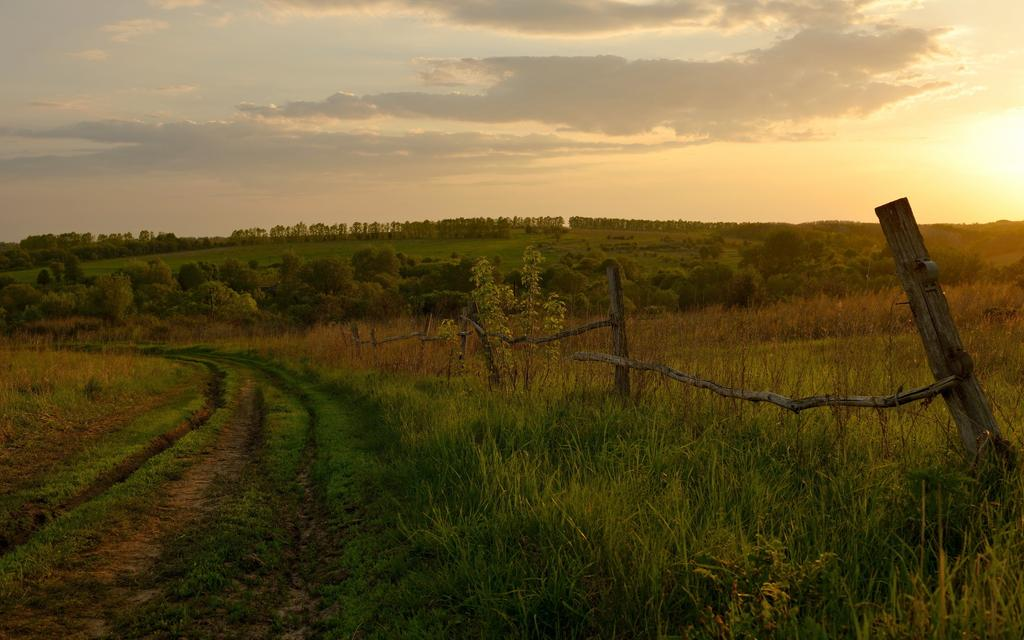What is located in the center of the image? There are trees, grass, plants, and fencing in the center of the image. What type of vegetation can be seen in the image? Trees, grass, and plants are visible in the image. What is the material of the fencing in the image? The fencing in the image is made of a material that is not specified in the facts. What part of the natural environment is visible at the bottom of the image? The ground is visible at the bottom of the image. What can be seen in the sky at the top of the image? Clouds are present in the sky at the top of the image. What is the value of the group of people standing near the trees in the image? There are no people present in the image, so it is not possible to determine the value of any group. What type of ground is visible at the bottom of the image? The type of ground is not specified in the facts, so it cannot be determined from the image. 